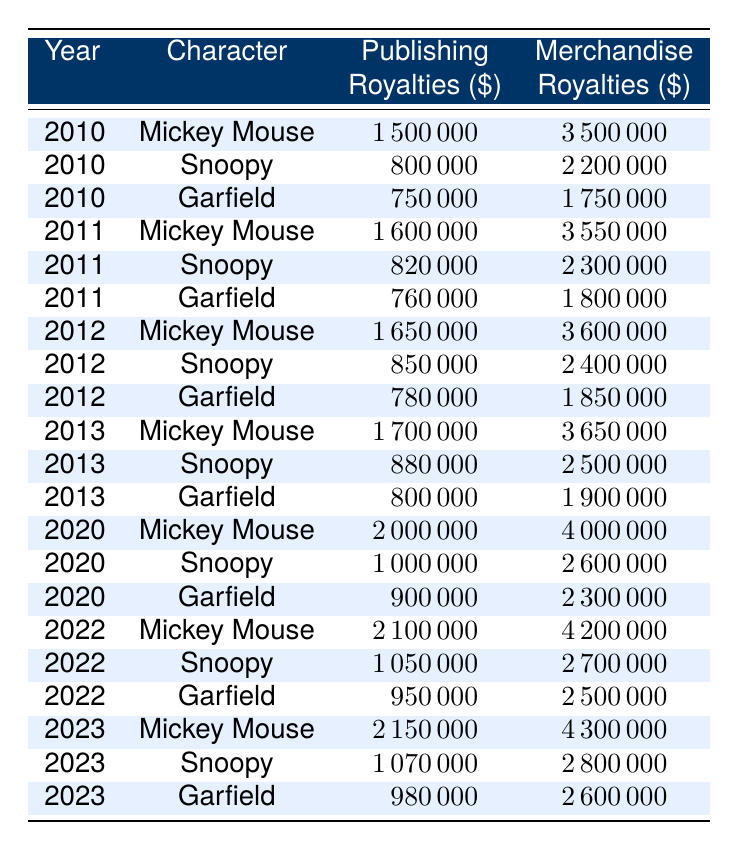What were the merchandise royalties for Mickey Mouse in 2013? In 2013, the table shows that Mickey Mouse earned merchandise royalties of 3,650,000 dollars.
Answer: 3,650,000 What was the total publishing royalties earned by Snoopy from 2010 to 2013? To find the total publishing royalties for Snoopy, we sum the amounts from each year: 800,000 (2010) + 820,000 (2011) + 850,000 (2012) + 880,000 (2013) = 3,350,000 dollars.
Answer: 3,350,000 Did Garfield earn more in merchandise royalties in 2022 than in 2020? By comparing the figures, Garfield earned 2,500,000 dollars in merchandise royalties in 2022 and 2,300,000 dollars in 2020, which means he did earn more in 2022.
Answer: Yes Which character had the highest total royalties in 2022, and what was that amount? In 2022, we calculate total royalties for each character: Mickey Mouse: 2,100,000 (publishing) + 4,200,000 (merchandise) = 6,300,000; Snoopy: 1,050,000 + 2,700,000 = 3,750,000; Garfield: 950,000 + 2,500,000 = 3,450,000. Mickey Mouse had the highest total at 6,300,000 dollars.
Answer: Mickey Mouse, 6,300,000 What year saw the highest publishing royalties for Mickey Mouse? By examining the table, we see the publishing royalties for Mickey Mouse were 2,150,000 in 2023, which is greater than any amount in previous years. Therefore, 2023 saw the highest publishing royalties.
Answer: 2023 What is the average merchandise royalties from 2010 to 2013 for Snoopy? To find the average, we first sum the merchandise royalties: 2,200,000 (2010) + 2,300,000 (2011) + 2,400,000 (2012) + 2,500,000 (2013) = 9,400,000. Dividing this sum by 4 gives us the average: 9,400,000 / 4 = 2,350,000 dollars.
Answer: 2,350,000 